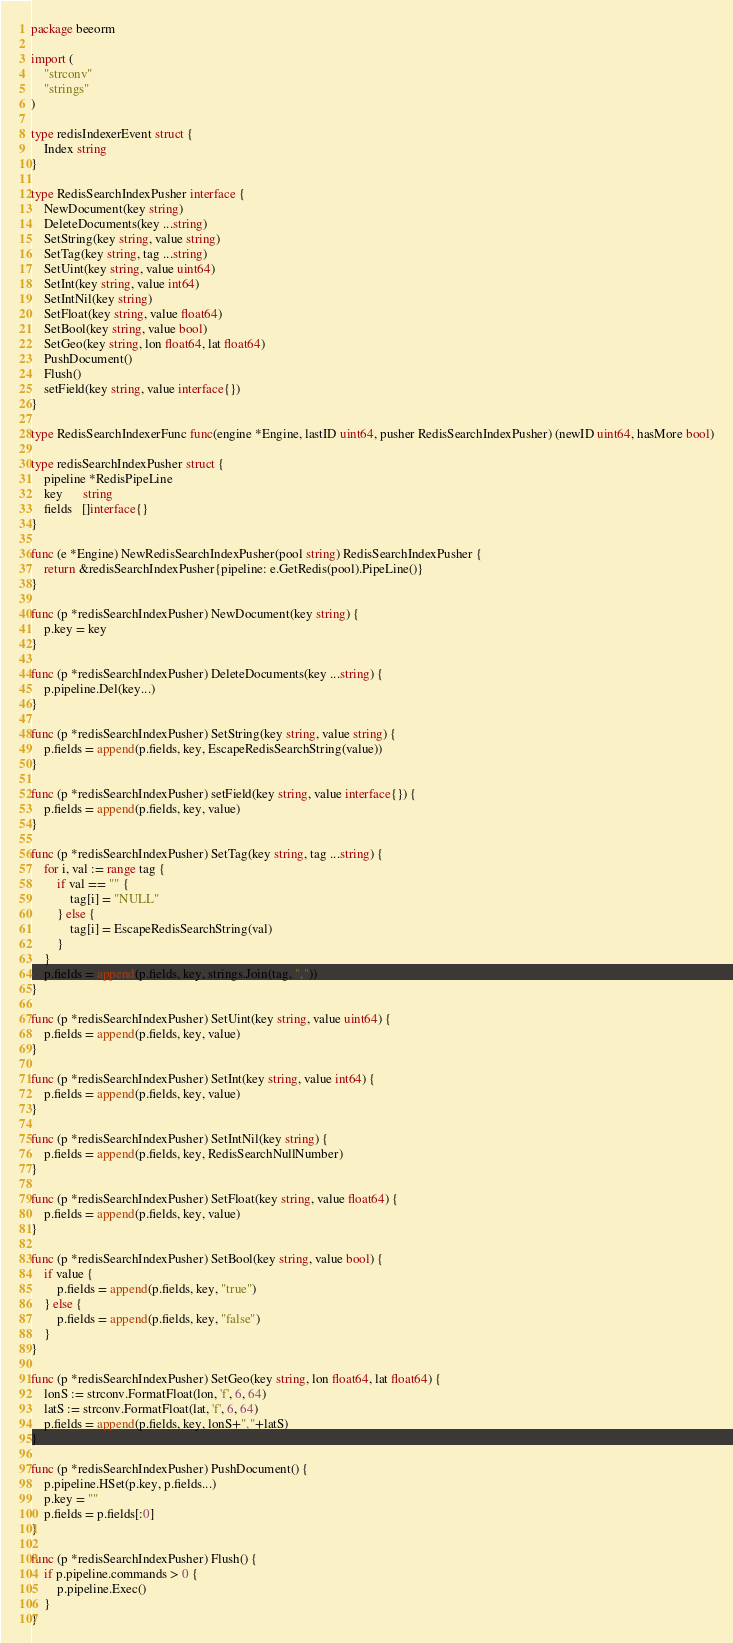<code> <loc_0><loc_0><loc_500><loc_500><_Go_>package beeorm

import (
	"strconv"
	"strings"
)

type redisIndexerEvent struct {
	Index string
}

type RedisSearchIndexPusher interface {
	NewDocument(key string)
	DeleteDocuments(key ...string)
	SetString(key string, value string)
	SetTag(key string, tag ...string)
	SetUint(key string, value uint64)
	SetInt(key string, value int64)
	SetIntNil(key string)
	SetFloat(key string, value float64)
	SetBool(key string, value bool)
	SetGeo(key string, lon float64, lat float64)
	PushDocument()
	Flush()
	setField(key string, value interface{})
}

type RedisSearchIndexerFunc func(engine *Engine, lastID uint64, pusher RedisSearchIndexPusher) (newID uint64, hasMore bool)

type redisSearchIndexPusher struct {
	pipeline *RedisPipeLine
	key      string
	fields   []interface{}
}

func (e *Engine) NewRedisSearchIndexPusher(pool string) RedisSearchIndexPusher {
	return &redisSearchIndexPusher{pipeline: e.GetRedis(pool).PipeLine()}
}

func (p *redisSearchIndexPusher) NewDocument(key string) {
	p.key = key
}

func (p *redisSearchIndexPusher) DeleteDocuments(key ...string) {
	p.pipeline.Del(key...)
}

func (p *redisSearchIndexPusher) SetString(key string, value string) {
	p.fields = append(p.fields, key, EscapeRedisSearchString(value))
}

func (p *redisSearchIndexPusher) setField(key string, value interface{}) {
	p.fields = append(p.fields, key, value)
}

func (p *redisSearchIndexPusher) SetTag(key string, tag ...string) {
	for i, val := range tag {
		if val == "" {
			tag[i] = "NULL"
		} else {
			tag[i] = EscapeRedisSearchString(val)
		}
	}
	p.fields = append(p.fields, key, strings.Join(tag, ","))
}

func (p *redisSearchIndexPusher) SetUint(key string, value uint64) {
	p.fields = append(p.fields, key, value)
}

func (p *redisSearchIndexPusher) SetInt(key string, value int64) {
	p.fields = append(p.fields, key, value)
}

func (p *redisSearchIndexPusher) SetIntNil(key string) {
	p.fields = append(p.fields, key, RedisSearchNullNumber)
}

func (p *redisSearchIndexPusher) SetFloat(key string, value float64) {
	p.fields = append(p.fields, key, value)
}

func (p *redisSearchIndexPusher) SetBool(key string, value bool) {
	if value {
		p.fields = append(p.fields, key, "true")
	} else {
		p.fields = append(p.fields, key, "false")
	}
}

func (p *redisSearchIndexPusher) SetGeo(key string, lon float64, lat float64) {
	lonS := strconv.FormatFloat(lon, 'f', 6, 64)
	latS := strconv.FormatFloat(lat, 'f', 6, 64)
	p.fields = append(p.fields, key, lonS+","+latS)
}

func (p *redisSearchIndexPusher) PushDocument() {
	p.pipeline.HSet(p.key, p.fields...)
	p.key = ""
	p.fields = p.fields[:0]
}

func (p *redisSearchIndexPusher) Flush() {
	if p.pipeline.commands > 0 {
		p.pipeline.Exec()
	}
}
</code> 